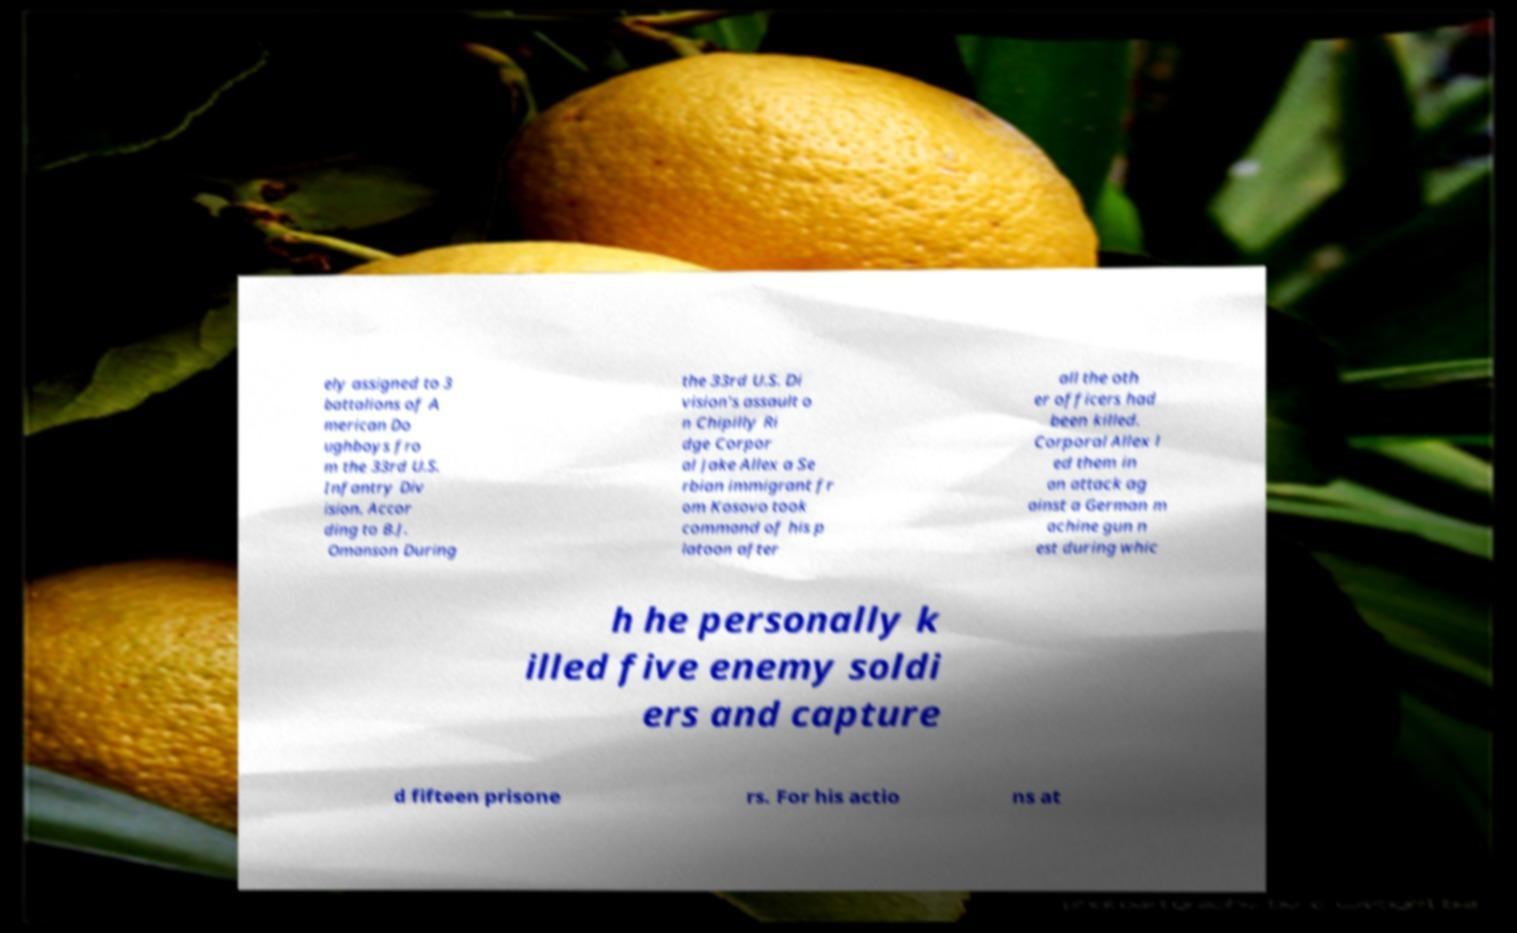Could you extract and type out the text from this image? ely assigned to 3 battalions of A merican Do ughboys fro m the 33rd U.S. Infantry Div ision. Accor ding to B.J. Omanson During the 33rd U.S. Di vision's assault o n Chipilly Ri dge Corpor al Jake Allex a Se rbian immigrant fr om Kosovo took command of his p latoon after all the oth er officers had been killed. Corporal Allex l ed them in an attack ag ainst a German m achine gun n est during whic h he personally k illed five enemy soldi ers and capture d fifteen prisone rs. For his actio ns at 